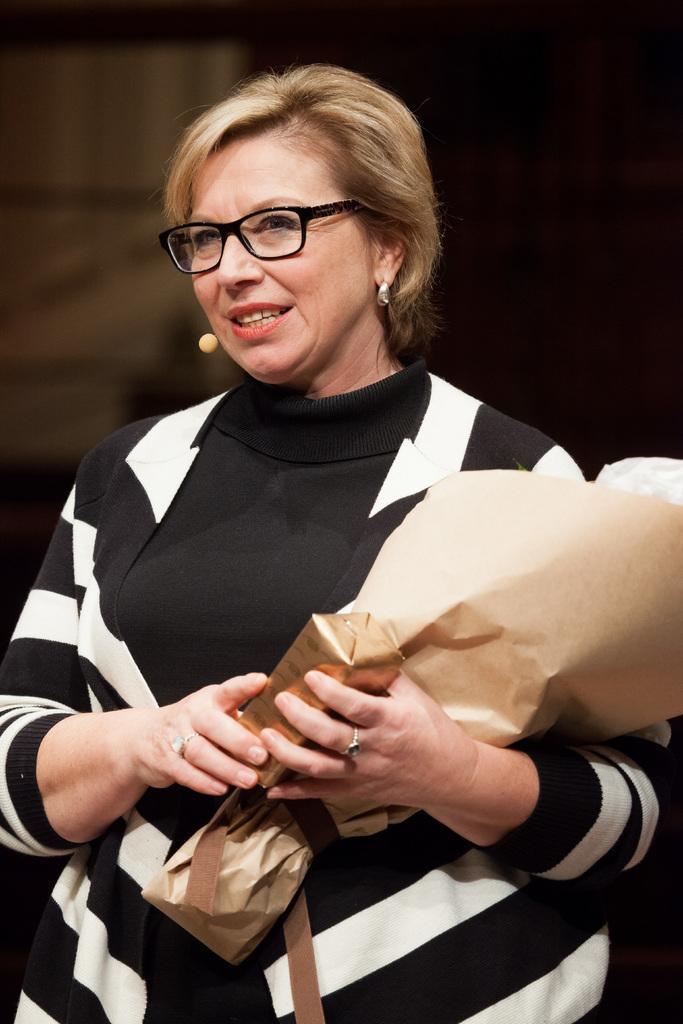Could you give a brief overview of what you see in this image? In this picture there is a woman standing and holding a flower bouquet. The background is blurred. 